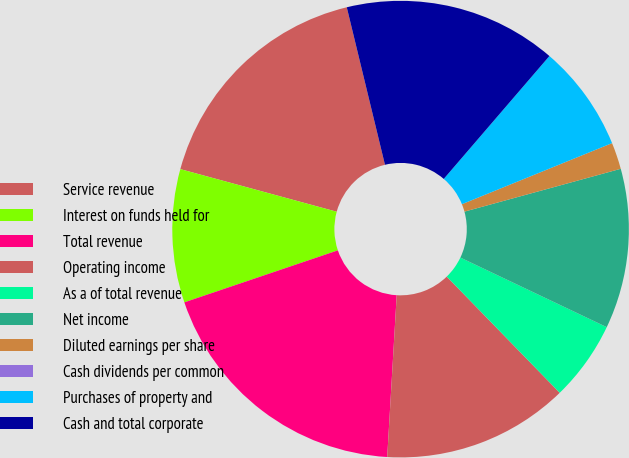<chart> <loc_0><loc_0><loc_500><loc_500><pie_chart><fcel>Service revenue<fcel>Interest on funds held for<fcel>Total revenue<fcel>Operating income<fcel>As a of total revenue<fcel>Net income<fcel>Diluted earnings per share<fcel>Cash dividends per common<fcel>Purchases of property and<fcel>Cash and total corporate<nl><fcel>16.98%<fcel>9.43%<fcel>18.87%<fcel>13.21%<fcel>5.66%<fcel>11.32%<fcel>1.89%<fcel>0.0%<fcel>7.55%<fcel>15.09%<nl></chart> 